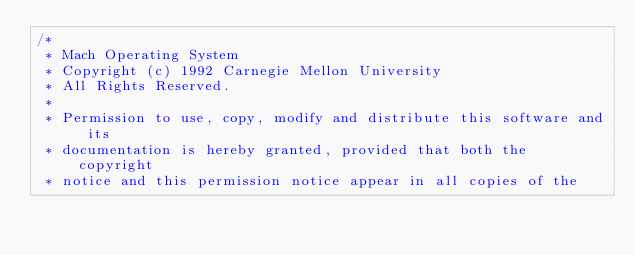Convert code to text. <code><loc_0><loc_0><loc_500><loc_500><_C_>/* 
 * Mach Operating System
 * Copyright (c) 1992 Carnegie Mellon University
 * All Rights Reserved.
 * 
 * Permission to use, copy, modify and distribute this software and its
 * documentation is hereby granted, provided that both the copyright
 * notice and this permission notice appear in all copies of the</code> 